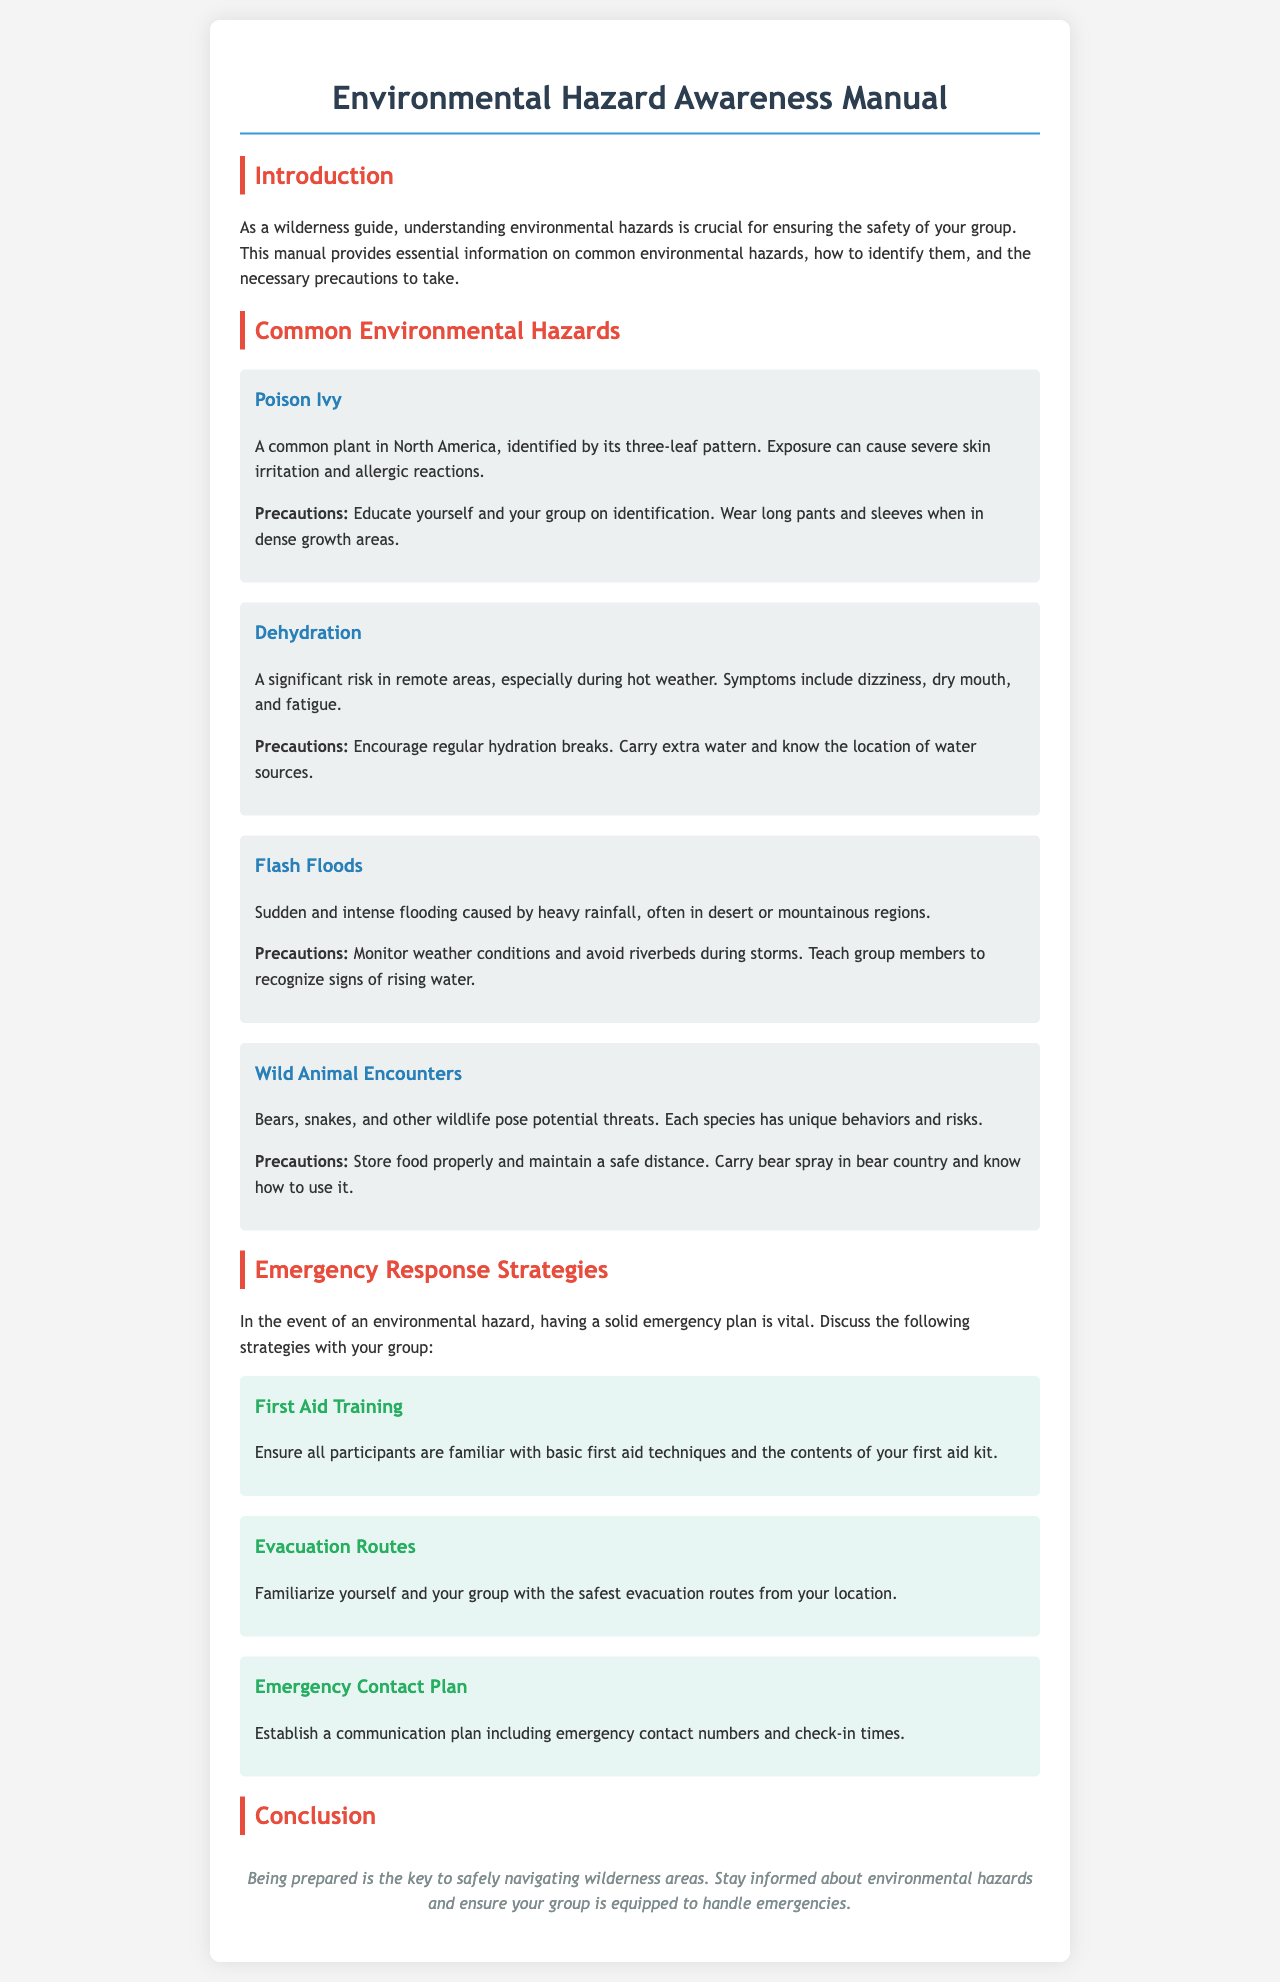What are the three leaves identified in Poison Ivy? Poison Ivy is identified by its three-leaf pattern as mentioned in the document.
Answer: three-leaf pattern What is a significant risk in remote areas? The document states that dehydration is a significant risk in remote areas, especially during hot weather.
Answer: Dehydration What should you monitor to avoid flash floods? To avoid flash floods, the document advises monitoring weather conditions.
Answer: Weather conditions What is one precaution for wild animal encounters? One precaution mentioned is to store food properly and maintain a safe distance from wildlife.
Answer: Store food properly What should all participants be familiar with in an emergency? The document emphasizes that all participants should be familiar with basic first aid techniques.
Answer: Basic first aid techniques How should you establish communication during an emergency? The document suggests establishing a communication plan including emergency contact numbers and check-in times.
Answer: Communication plan What is essential for safely navigating wilderness areas according to the conclusion? The conclusion states that being prepared is the key to safely navigating wilderness areas.
Answer: Being prepared What should you familiarize your group with in case of an emergency? The document recommends familiarizing your group with the safest evacuation routes from your location.
Answer: Evacuation routes 